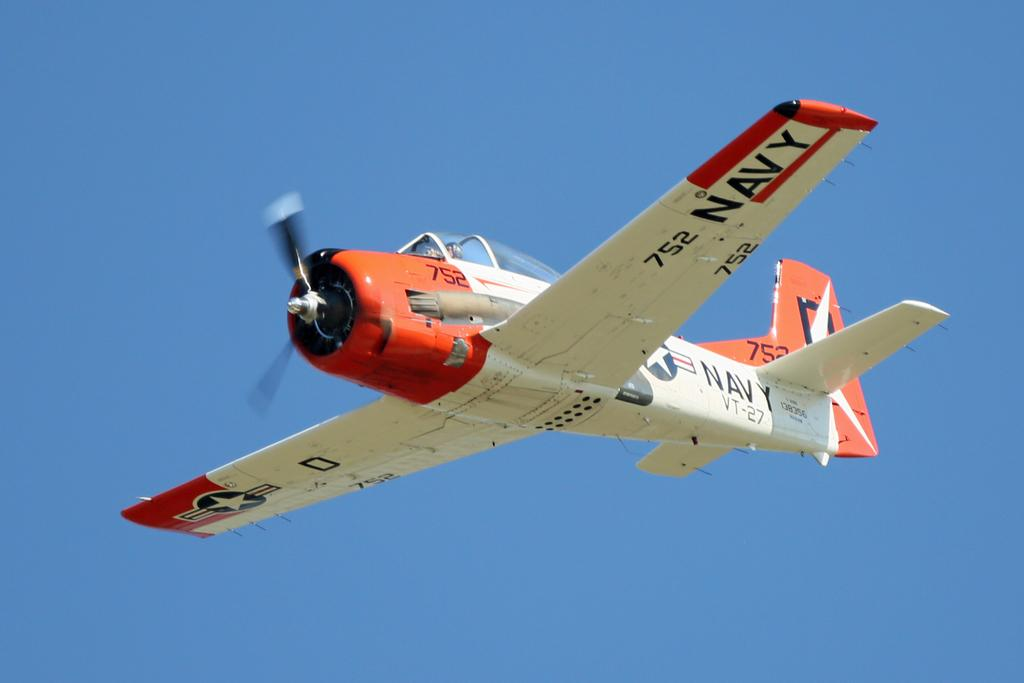Provide a one-sentence caption for the provided image. An aerial shot of a plane with the word Navy on one of it's wings. 